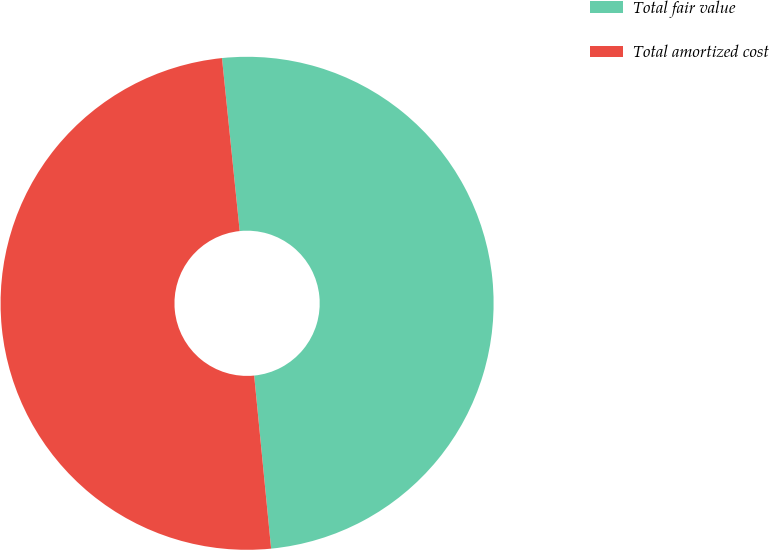<chart> <loc_0><loc_0><loc_500><loc_500><pie_chart><fcel>Total fair value<fcel>Total amortized cost<nl><fcel>50.07%<fcel>49.93%<nl></chart> 